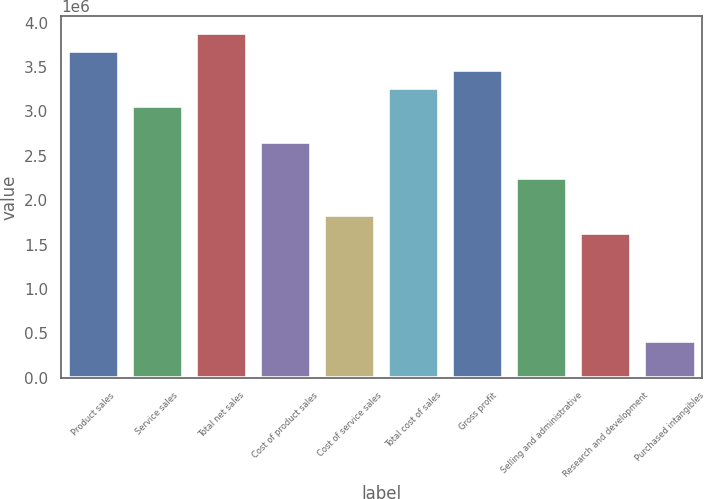Convert chart to OTSL. <chart><loc_0><loc_0><loc_500><loc_500><bar_chart><fcel>Product sales<fcel>Service sales<fcel>Total net sales<fcel>Cost of product sales<fcel>Cost of service sales<fcel>Total cost of sales<fcel>Gross profit<fcel>Selling and administrative<fcel>Research and development<fcel>Purchased intangibles<nl><fcel>3.67619e+06<fcel>3.0635e+06<fcel>3.88043e+06<fcel>2.65503e+06<fcel>1.8381e+06<fcel>3.26773e+06<fcel>3.47196e+06<fcel>2.24656e+06<fcel>1.63387e+06<fcel>408471<nl></chart> 